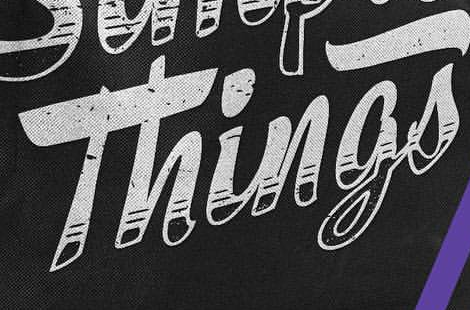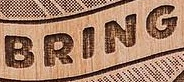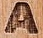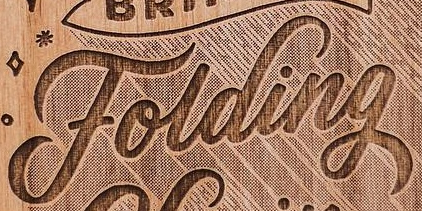What text is displayed in these images sequentially, separated by a semicolon? Things; BRING; A; Folding 